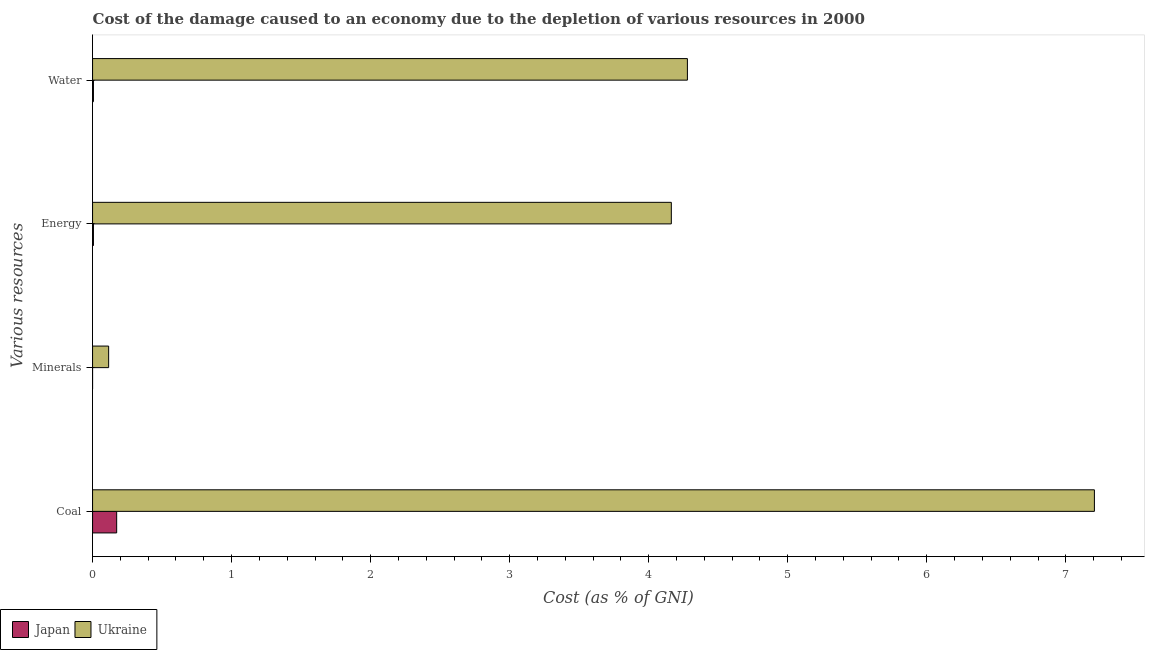How many different coloured bars are there?
Ensure brevity in your answer.  2. Are the number of bars per tick equal to the number of legend labels?
Provide a succinct answer. Yes. How many bars are there on the 4th tick from the top?
Provide a succinct answer. 2. How many bars are there on the 1st tick from the bottom?
Give a very brief answer. 2. What is the label of the 3rd group of bars from the top?
Your answer should be very brief. Minerals. What is the cost of damage due to depletion of coal in Ukraine?
Your response must be concise. 7.21. Across all countries, what is the maximum cost of damage due to depletion of coal?
Give a very brief answer. 7.21. Across all countries, what is the minimum cost of damage due to depletion of water?
Your answer should be very brief. 0.01. In which country was the cost of damage due to depletion of energy maximum?
Offer a terse response. Ukraine. In which country was the cost of damage due to depletion of coal minimum?
Provide a succinct answer. Japan. What is the total cost of damage due to depletion of energy in the graph?
Provide a succinct answer. 4.17. What is the difference between the cost of damage due to depletion of coal in Japan and that in Ukraine?
Provide a short and direct response. -7.03. What is the difference between the cost of damage due to depletion of water in Ukraine and the cost of damage due to depletion of coal in Japan?
Ensure brevity in your answer.  4.11. What is the average cost of damage due to depletion of water per country?
Keep it short and to the point. 2.14. What is the difference between the cost of damage due to depletion of energy and cost of damage due to depletion of coal in Japan?
Offer a terse response. -0.17. What is the ratio of the cost of damage due to depletion of coal in Japan to that in Ukraine?
Give a very brief answer. 0.02. Is the cost of damage due to depletion of minerals in Ukraine less than that in Japan?
Make the answer very short. No. Is the difference between the cost of damage due to depletion of minerals in Japan and Ukraine greater than the difference between the cost of damage due to depletion of coal in Japan and Ukraine?
Your answer should be compact. Yes. What is the difference between the highest and the second highest cost of damage due to depletion of energy?
Make the answer very short. 4.16. What is the difference between the highest and the lowest cost of damage due to depletion of minerals?
Offer a very short reply. 0.12. In how many countries, is the cost of damage due to depletion of water greater than the average cost of damage due to depletion of water taken over all countries?
Offer a very short reply. 1. Is it the case that in every country, the sum of the cost of damage due to depletion of coal and cost of damage due to depletion of water is greater than the sum of cost of damage due to depletion of minerals and cost of damage due to depletion of energy?
Offer a very short reply. No. What does the 1st bar from the top in Energy represents?
Your answer should be very brief. Ukraine. What does the 2nd bar from the bottom in Water represents?
Provide a succinct answer. Ukraine. Is it the case that in every country, the sum of the cost of damage due to depletion of coal and cost of damage due to depletion of minerals is greater than the cost of damage due to depletion of energy?
Offer a very short reply. Yes. How many bars are there?
Provide a short and direct response. 8. Are all the bars in the graph horizontal?
Provide a short and direct response. Yes. Does the graph contain grids?
Your response must be concise. No. Where does the legend appear in the graph?
Keep it short and to the point. Bottom left. How many legend labels are there?
Make the answer very short. 2. How are the legend labels stacked?
Make the answer very short. Horizontal. What is the title of the graph?
Provide a succinct answer. Cost of the damage caused to an economy due to the depletion of various resources in 2000 . What is the label or title of the X-axis?
Your answer should be compact. Cost (as % of GNI). What is the label or title of the Y-axis?
Your answer should be very brief. Various resources. What is the Cost (as % of GNI) in Japan in Coal?
Provide a succinct answer. 0.17. What is the Cost (as % of GNI) of Ukraine in Coal?
Your answer should be compact. 7.21. What is the Cost (as % of GNI) of Japan in Minerals?
Make the answer very short. 7.461786862646801e-6. What is the Cost (as % of GNI) of Ukraine in Minerals?
Provide a succinct answer. 0.12. What is the Cost (as % of GNI) in Japan in Energy?
Provide a succinct answer. 0.01. What is the Cost (as % of GNI) in Ukraine in Energy?
Your answer should be compact. 4.16. What is the Cost (as % of GNI) of Japan in Water?
Make the answer very short. 0.01. What is the Cost (as % of GNI) in Ukraine in Water?
Offer a very short reply. 4.28. Across all Various resources, what is the maximum Cost (as % of GNI) of Japan?
Provide a short and direct response. 0.17. Across all Various resources, what is the maximum Cost (as % of GNI) of Ukraine?
Give a very brief answer. 7.21. Across all Various resources, what is the minimum Cost (as % of GNI) in Japan?
Make the answer very short. 7.461786862646801e-6. Across all Various resources, what is the minimum Cost (as % of GNI) in Ukraine?
Offer a very short reply. 0.12. What is the total Cost (as % of GNI) in Japan in the graph?
Keep it short and to the point. 0.19. What is the total Cost (as % of GNI) in Ukraine in the graph?
Keep it short and to the point. 15.76. What is the difference between the Cost (as % of GNI) of Japan in Coal and that in Minerals?
Give a very brief answer. 0.17. What is the difference between the Cost (as % of GNI) of Ukraine in Coal and that in Minerals?
Ensure brevity in your answer.  7.09. What is the difference between the Cost (as % of GNI) in Japan in Coal and that in Energy?
Your answer should be compact. 0.17. What is the difference between the Cost (as % of GNI) of Ukraine in Coal and that in Energy?
Make the answer very short. 3.04. What is the difference between the Cost (as % of GNI) in Japan in Coal and that in Water?
Your response must be concise. 0.17. What is the difference between the Cost (as % of GNI) in Ukraine in Coal and that in Water?
Your answer should be very brief. 2.93. What is the difference between the Cost (as % of GNI) in Japan in Minerals and that in Energy?
Your answer should be very brief. -0.01. What is the difference between the Cost (as % of GNI) in Ukraine in Minerals and that in Energy?
Your response must be concise. -4.05. What is the difference between the Cost (as % of GNI) of Japan in Minerals and that in Water?
Make the answer very short. -0.01. What is the difference between the Cost (as % of GNI) of Ukraine in Minerals and that in Water?
Ensure brevity in your answer.  -4.16. What is the difference between the Cost (as % of GNI) of Japan in Energy and that in Water?
Provide a short and direct response. -0. What is the difference between the Cost (as % of GNI) in Ukraine in Energy and that in Water?
Offer a terse response. -0.12. What is the difference between the Cost (as % of GNI) in Japan in Coal and the Cost (as % of GNI) in Ukraine in Minerals?
Provide a succinct answer. 0.06. What is the difference between the Cost (as % of GNI) of Japan in Coal and the Cost (as % of GNI) of Ukraine in Energy?
Give a very brief answer. -3.99. What is the difference between the Cost (as % of GNI) of Japan in Coal and the Cost (as % of GNI) of Ukraine in Water?
Keep it short and to the point. -4.11. What is the difference between the Cost (as % of GNI) of Japan in Minerals and the Cost (as % of GNI) of Ukraine in Energy?
Your answer should be compact. -4.16. What is the difference between the Cost (as % of GNI) of Japan in Minerals and the Cost (as % of GNI) of Ukraine in Water?
Keep it short and to the point. -4.28. What is the difference between the Cost (as % of GNI) in Japan in Energy and the Cost (as % of GNI) in Ukraine in Water?
Your answer should be very brief. -4.27. What is the average Cost (as % of GNI) of Japan per Various resources?
Ensure brevity in your answer.  0.05. What is the average Cost (as % of GNI) of Ukraine per Various resources?
Your answer should be compact. 3.94. What is the difference between the Cost (as % of GNI) in Japan and Cost (as % of GNI) in Ukraine in Coal?
Your response must be concise. -7.03. What is the difference between the Cost (as % of GNI) in Japan and Cost (as % of GNI) in Ukraine in Minerals?
Your answer should be very brief. -0.12. What is the difference between the Cost (as % of GNI) in Japan and Cost (as % of GNI) in Ukraine in Energy?
Your response must be concise. -4.16. What is the difference between the Cost (as % of GNI) in Japan and Cost (as % of GNI) in Ukraine in Water?
Provide a succinct answer. -4.27. What is the ratio of the Cost (as % of GNI) of Japan in Coal to that in Minerals?
Your answer should be very brief. 2.32e+04. What is the ratio of the Cost (as % of GNI) in Ukraine in Coal to that in Minerals?
Ensure brevity in your answer.  62.34. What is the ratio of the Cost (as % of GNI) of Japan in Coal to that in Energy?
Provide a succinct answer. 27.83. What is the ratio of the Cost (as % of GNI) of Ukraine in Coal to that in Energy?
Your answer should be compact. 1.73. What is the ratio of the Cost (as % of GNI) in Japan in Coal to that in Water?
Your answer should be compact. 27.8. What is the ratio of the Cost (as % of GNI) of Ukraine in Coal to that in Water?
Provide a succinct answer. 1.68. What is the ratio of the Cost (as % of GNI) of Japan in Minerals to that in Energy?
Offer a terse response. 0. What is the ratio of the Cost (as % of GNI) in Ukraine in Minerals to that in Energy?
Ensure brevity in your answer.  0.03. What is the ratio of the Cost (as % of GNI) of Japan in Minerals to that in Water?
Your answer should be very brief. 0. What is the ratio of the Cost (as % of GNI) of Ukraine in Minerals to that in Water?
Give a very brief answer. 0.03. What is the difference between the highest and the second highest Cost (as % of GNI) of Japan?
Give a very brief answer. 0.17. What is the difference between the highest and the second highest Cost (as % of GNI) in Ukraine?
Give a very brief answer. 2.93. What is the difference between the highest and the lowest Cost (as % of GNI) in Japan?
Your answer should be very brief. 0.17. What is the difference between the highest and the lowest Cost (as % of GNI) in Ukraine?
Your response must be concise. 7.09. 